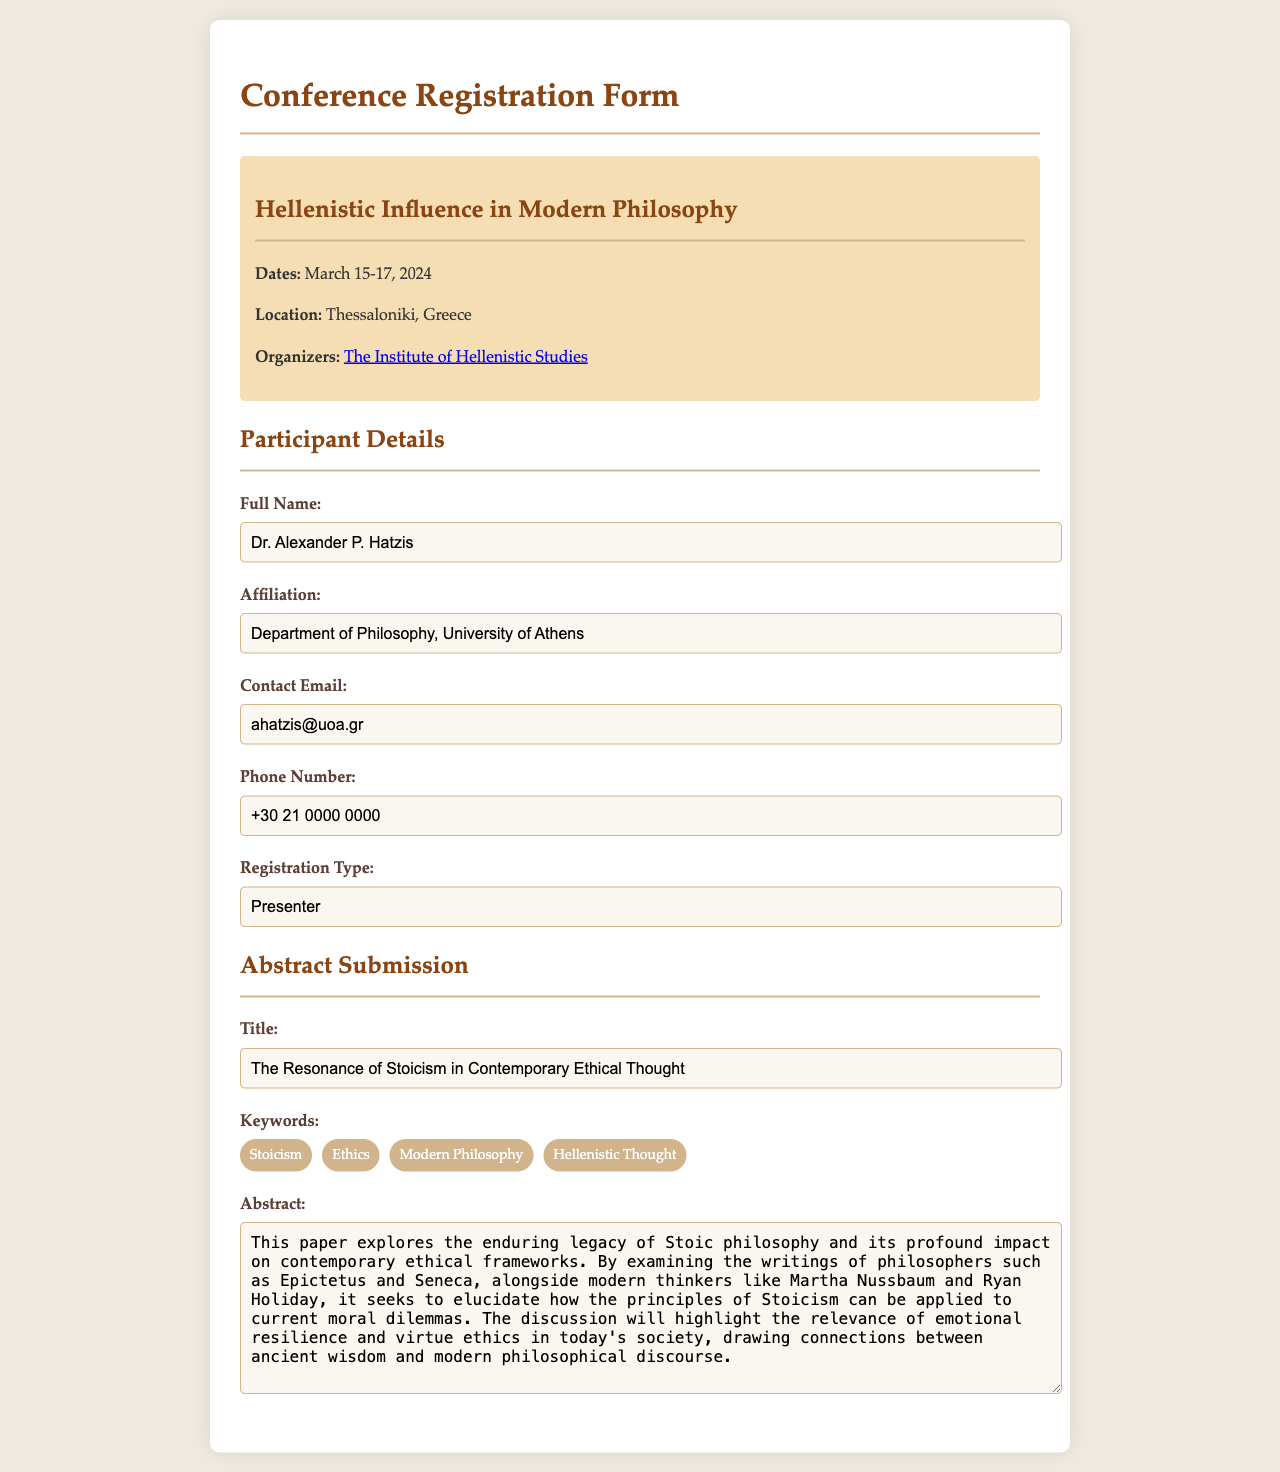What is the title of the conference? The title of the conference is provided in the document, specifically indicated in the conference info section.
Answer: Hellenistic Influence in Modern Philosophy Who is the presenter? The presenter’s name is filled out in the participant details section of the form.
Answer: Dr. Alexander P. Hatzis What are the dates of the conference? The dates of the conference are listed explicitly in the conference information.
Answer: March 15-17, 2024 What is the abstract title? The abstract title is provided under the abstract submission section of the form.
Answer: The Resonance of Stoicism in Contemporary Ethical Thought Which institution is organizing the conference? The organizing institution is mentioned in the conference information, and it indicates who is responsible for the event.
Answer: The Institute of Hellenistic Studies What is one of the keywords related to the abstract? Several keywords are listed in the keywords section related to the submitted abstract; mentioning one is sufficient.
Answer: Stoicism What is the contact email of the participant? The contact email is stated in the participant details, specifically in the corresponding input field.
Answer: ahatzis@uoa.gr What is the affiliation of the participant? The affiliation is mentioned in the participant details section and indicates the academic relationship of the participant.
Answer: Department of Philosophy, University of Athens 